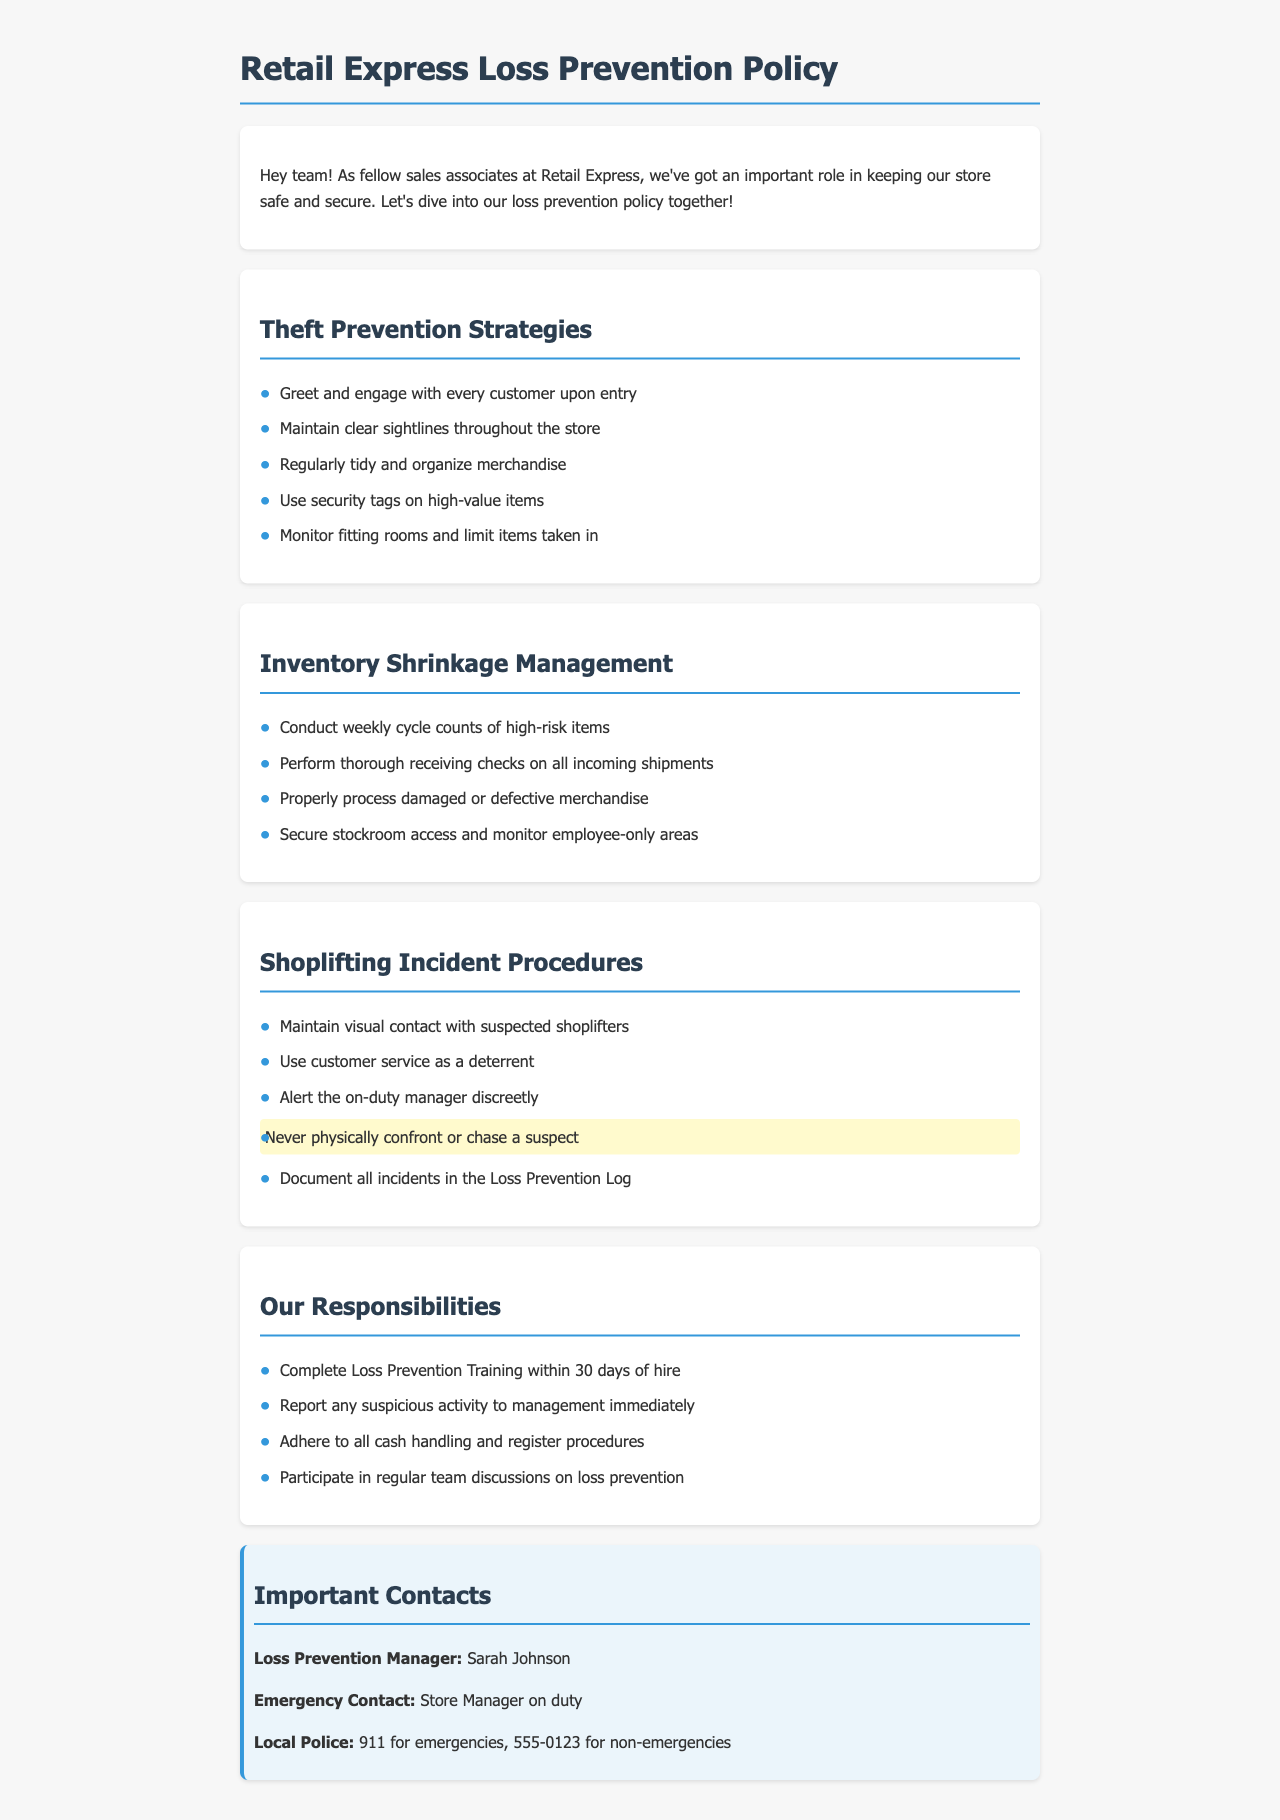What are the theft prevention strategies? The theft prevention strategies are listed in the document as bullet points, including greeting customers and maintaining sightlines.
Answer: Greet and engage with every customer upon entry; Maintain clear sightlines throughout the store; Regularly tidy and organize merchandise; Use security tags on high-value items; Monitor fitting rooms and limit items taken in Who should be alerted when a shoplifting incident is suspected? The document specifies that the on-duty manager should be alerted discreetly in case of a suspected shoplifting incident.
Answer: On-duty manager What is one key responsibility for new associates? The policy states that all new associates must complete Loss Prevention Training within a specific timeframe after hiring.
Answer: Complete Loss Prevention Training within 30 days of hire What is the emergency contact number for local police? The document provides contact information for emergencies, specifying the local police number for emergencies and non-emergencies.
Answer: 911 for emergencies What should be documented in the Loss Prevention Log? The document instructs associates to document all incidents of suspected shoplifting in a specific log.
Answer: All incidents Why should merchandise be organized regularly? Keeping merchandise tidy is one of the theft prevention strategies and contributes to loss prevention efforts.
Answer: To prevent theft 